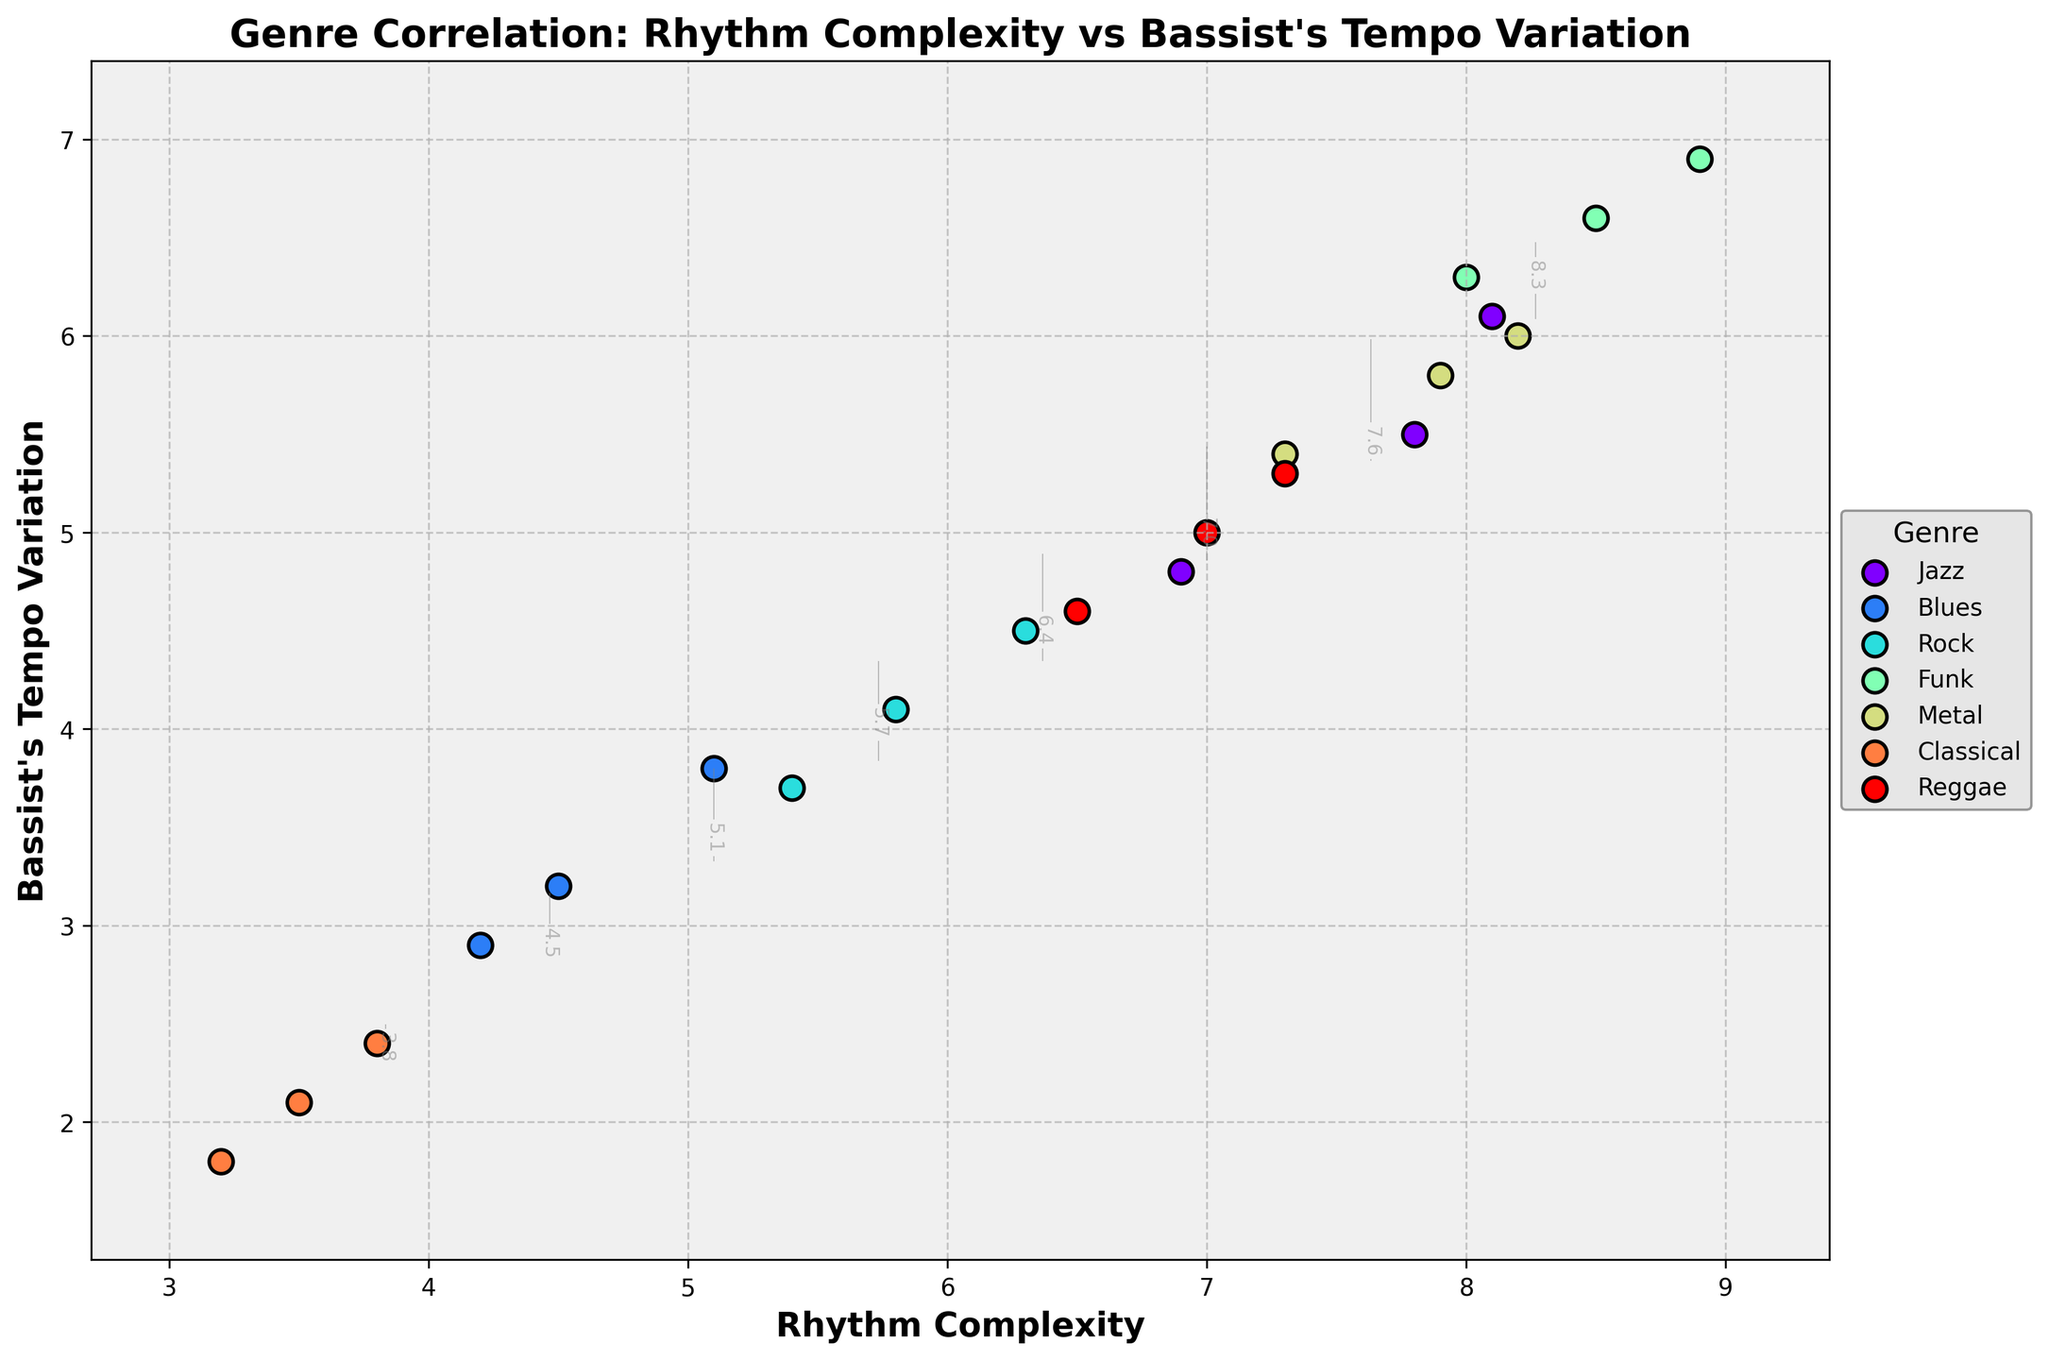What is the title of the figure? The title of the figure is clearly shown at the top, and it reads "Genre Correlation: Rhythm Complexity vs Bassist's Tempo Variation".
Answer: Genre Correlation: Rhythm Complexity vs Bassist's Tempo Variation Which genre has the highest rhythm complexity? By looking at the scatter points, Funk has the highest rhythm complexity with data points close to 8.9.
Answer: Funk What are the axis labels for the x and y axes? The x-axis is labeled "Rhythm Complexity" and the y-axis is labeled "Bassist's Tempo Variation".
Answer: Rhythm Complexity (x-axis), Bassist's Tempo Variation (y-axis) Among Jazz and Blues, which genre's data points show greater rhythm complexity? Comparing the scatter points of Jazz and Blues, Jazz has higher rhythm complexity values, with points around 7.8 to 8.1, while Blues is around 4.2 to 5.1.
Answer: Jazz Which genre tends to have lower values for both rhythm complexity and tempo variation? By observing the scatter points, Classical has the lowest values for both rhythm complexity and tempo variation, clustered around 3.2 to 3.8 for rhythm complexity and 1.8 to 2.4 for tempo variation.
Answer: Classical Can you identify any genres that show high correlation between rhythm complexity and bassist's tempo variation? Funk exhibits a high correlation between rhythm complexity and bassist's tempo variation, with its points clustered around higher values for both metrics.
Answer: Funk What is the range of bassist's tempo variation for the Rock genre? Observing the Rock data points, the bassist's tempo variation ranges from approximately 3.7 to 4.5.
Answer: 3.7 to 4.5 Which genre exhibits the greatest spread in rhythm complexity? The Jazz genre shows the greatest spread in rhythm complexity with a range from about 6.9 to 8.1.
Answer: Jazz What contour levels are displayed in the plot? The contour levels, indicated by gray lines with labels, range from the minimum to the maximum of rhythm complexity values in increments, appearing around every 1 unit.
Answer: Approximately from 3 to 9 in 1 unit increments How do Tempo Variation and Rhythm Complexity correlate in Reggae? Reggae shows a moderate correlation between rhythm complexity and tempo variation, with points plotted between 6.5 to 7.3 for rhythm complexity and 4.6 to 5.3 for tempo variation.
Answer: Moderate correlation 